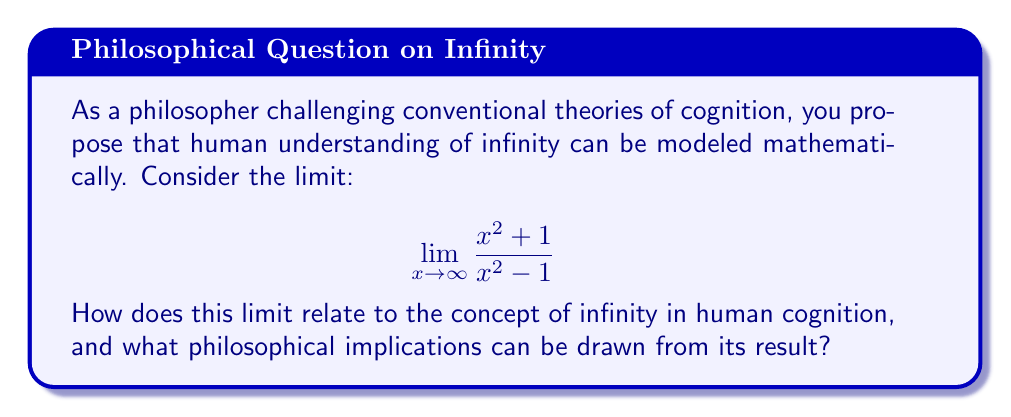Help me with this question. To approach this question, we need to evaluate the limit and then interpret its philosophical implications:

1. Evaluating the limit:
   $$\lim_{x \to \infty} \frac{x^2 + 1}{x^2 - 1}$$

   We can divide both numerator and denominator by $x^2$:
   $$\lim_{x \to \infty} \frac{1 + \frac{1}{x^2}}{1 - \frac{1}{x^2}}$$

   As $x$ approaches infinity, $\frac{1}{x^2}$ approaches 0:
   $$\lim_{x \to \infty} \frac{1 + 0}{1 - 0} = \frac{1}{1} = 1$$

2. Philosophical interpretation:
   The limit approaches 1, a finite value, despite dealing with infinity. This suggests that even when confronted with the concept of infinity, human cognition tends to resolve it into something finite and comprehensible.

   The process of taking the limit can be seen as analogous to how the human mind grapples with the concept of infinity:
   a) Initial overwhelm: The original fraction with $x$ approaching infinity seems daunting.
   b) Simplification: By dividing by $x^2$, we simplify the expression, much like how we might break down a complex concept.
   c) Resolution: The limit resolves to a simple, finite value, reflecting how we often try to "tame" infinity into something manageable.

   This mathematical process mirrors how human cognition might attempt to understand infinity by breaking it down and relating it to finite concepts we can grasp.

   The result challenges the notion that infinity is incomprehensible to human cognition. Instead, it suggests that our minds can approach infinite concepts through finite means, potentially indicating an inherent limitation or adaptation in human cognitive processes when dealing with the infinite.
Answer: The limit approaches 1, suggesting that human cognition may attempt to understand infinity by resolving it into finite, comprehensible concepts. This process reflects potential cognitive strategies for grappling with infinite concepts, challenging traditional views on the incomprehensibility of infinity to human understanding. 